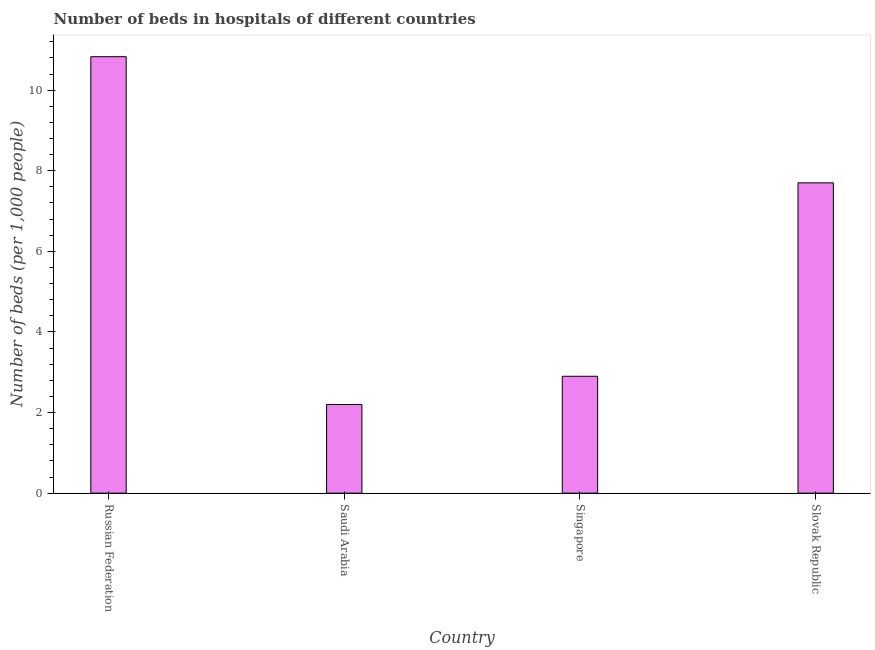Does the graph contain grids?
Give a very brief answer. No. What is the title of the graph?
Provide a short and direct response. Number of beds in hospitals of different countries. What is the label or title of the X-axis?
Provide a short and direct response. Country. What is the label or title of the Y-axis?
Offer a very short reply. Number of beds (per 1,0 people). What is the number of hospital beds in Slovak Republic?
Give a very brief answer. 7.7. Across all countries, what is the maximum number of hospital beds?
Your answer should be very brief. 10.83. Across all countries, what is the minimum number of hospital beds?
Make the answer very short. 2.2. In which country was the number of hospital beds maximum?
Give a very brief answer. Russian Federation. In which country was the number of hospital beds minimum?
Make the answer very short. Saudi Arabia. What is the sum of the number of hospital beds?
Offer a very short reply. 23.63. What is the difference between the number of hospital beds in Singapore and Slovak Republic?
Provide a short and direct response. -4.8. What is the average number of hospital beds per country?
Offer a very short reply. 5.91. What is the median number of hospital beds?
Keep it short and to the point. 5.3. In how many countries, is the number of hospital beds greater than 7.6 %?
Give a very brief answer. 2. What is the ratio of the number of hospital beds in Russian Federation to that in Slovak Republic?
Keep it short and to the point. 1.41. What is the difference between the highest and the second highest number of hospital beds?
Your answer should be very brief. 3.13. Is the sum of the number of hospital beds in Singapore and Slovak Republic greater than the maximum number of hospital beds across all countries?
Give a very brief answer. No. What is the difference between the highest and the lowest number of hospital beds?
Offer a very short reply. 8.63. How many bars are there?
Keep it short and to the point. 4. What is the difference between two consecutive major ticks on the Y-axis?
Your response must be concise. 2. What is the Number of beds (per 1,000 people) of Russian Federation?
Your answer should be compact. 10.83. What is the Number of beds (per 1,000 people) in Saudi Arabia?
Provide a succinct answer. 2.2. What is the Number of beds (per 1,000 people) of Singapore?
Provide a short and direct response. 2.9. What is the Number of beds (per 1,000 people) of Slovak Republic?
Give a very brief answer. 7.7. What is the difference between the Number of beds (per 1,000 people) in Russian Federation and Saudi Arabia?
Offer a terse response. 8.63. What is the difference between the Number of beds (per 1,000 people) in Russian Federation and Singapore?
Ensure brevity in your answer.  7.93. What is the difference between the Number of beds (per 1,000 people) in Russian Federation and Slovak Republic?
Ensure brevity in your answer.  3.13. What is the difference between the Number of beds (per 1,000 people) in Saudi Arabia and Singapore?
Your answer should be compact. -0.7. What is the ratio of the Number of beds (per 1,000 people) in Russian Federation to that in Saudi Arabia?
Your response must be concise. 4.92. What is the ratio of the Number of beds (per 1,000 people) in Russian Federation to that in Singapore?
Provide a succinct answer. 3.73. What is the ratio of the Number of beds (per 1,000 people) in Russian Federation to that in Slovak Republic?
Keep it short and to the point. 1.41. What is the ratio of the Number of beds (per 1,000 people) in Saudi Arabia to that in Singapore?
Provide a succinct answer. 0.76. What is the ratio of the Number of beds (per 1,000 people) in Saudi Arabia to that in Slovak Republic?
Make the answer very short. 0.29. What is the ratio of the Number of beds (per 1,000 people) in Singapore to that in Slovak Republic?
Offer a very short reply. 0.38. 